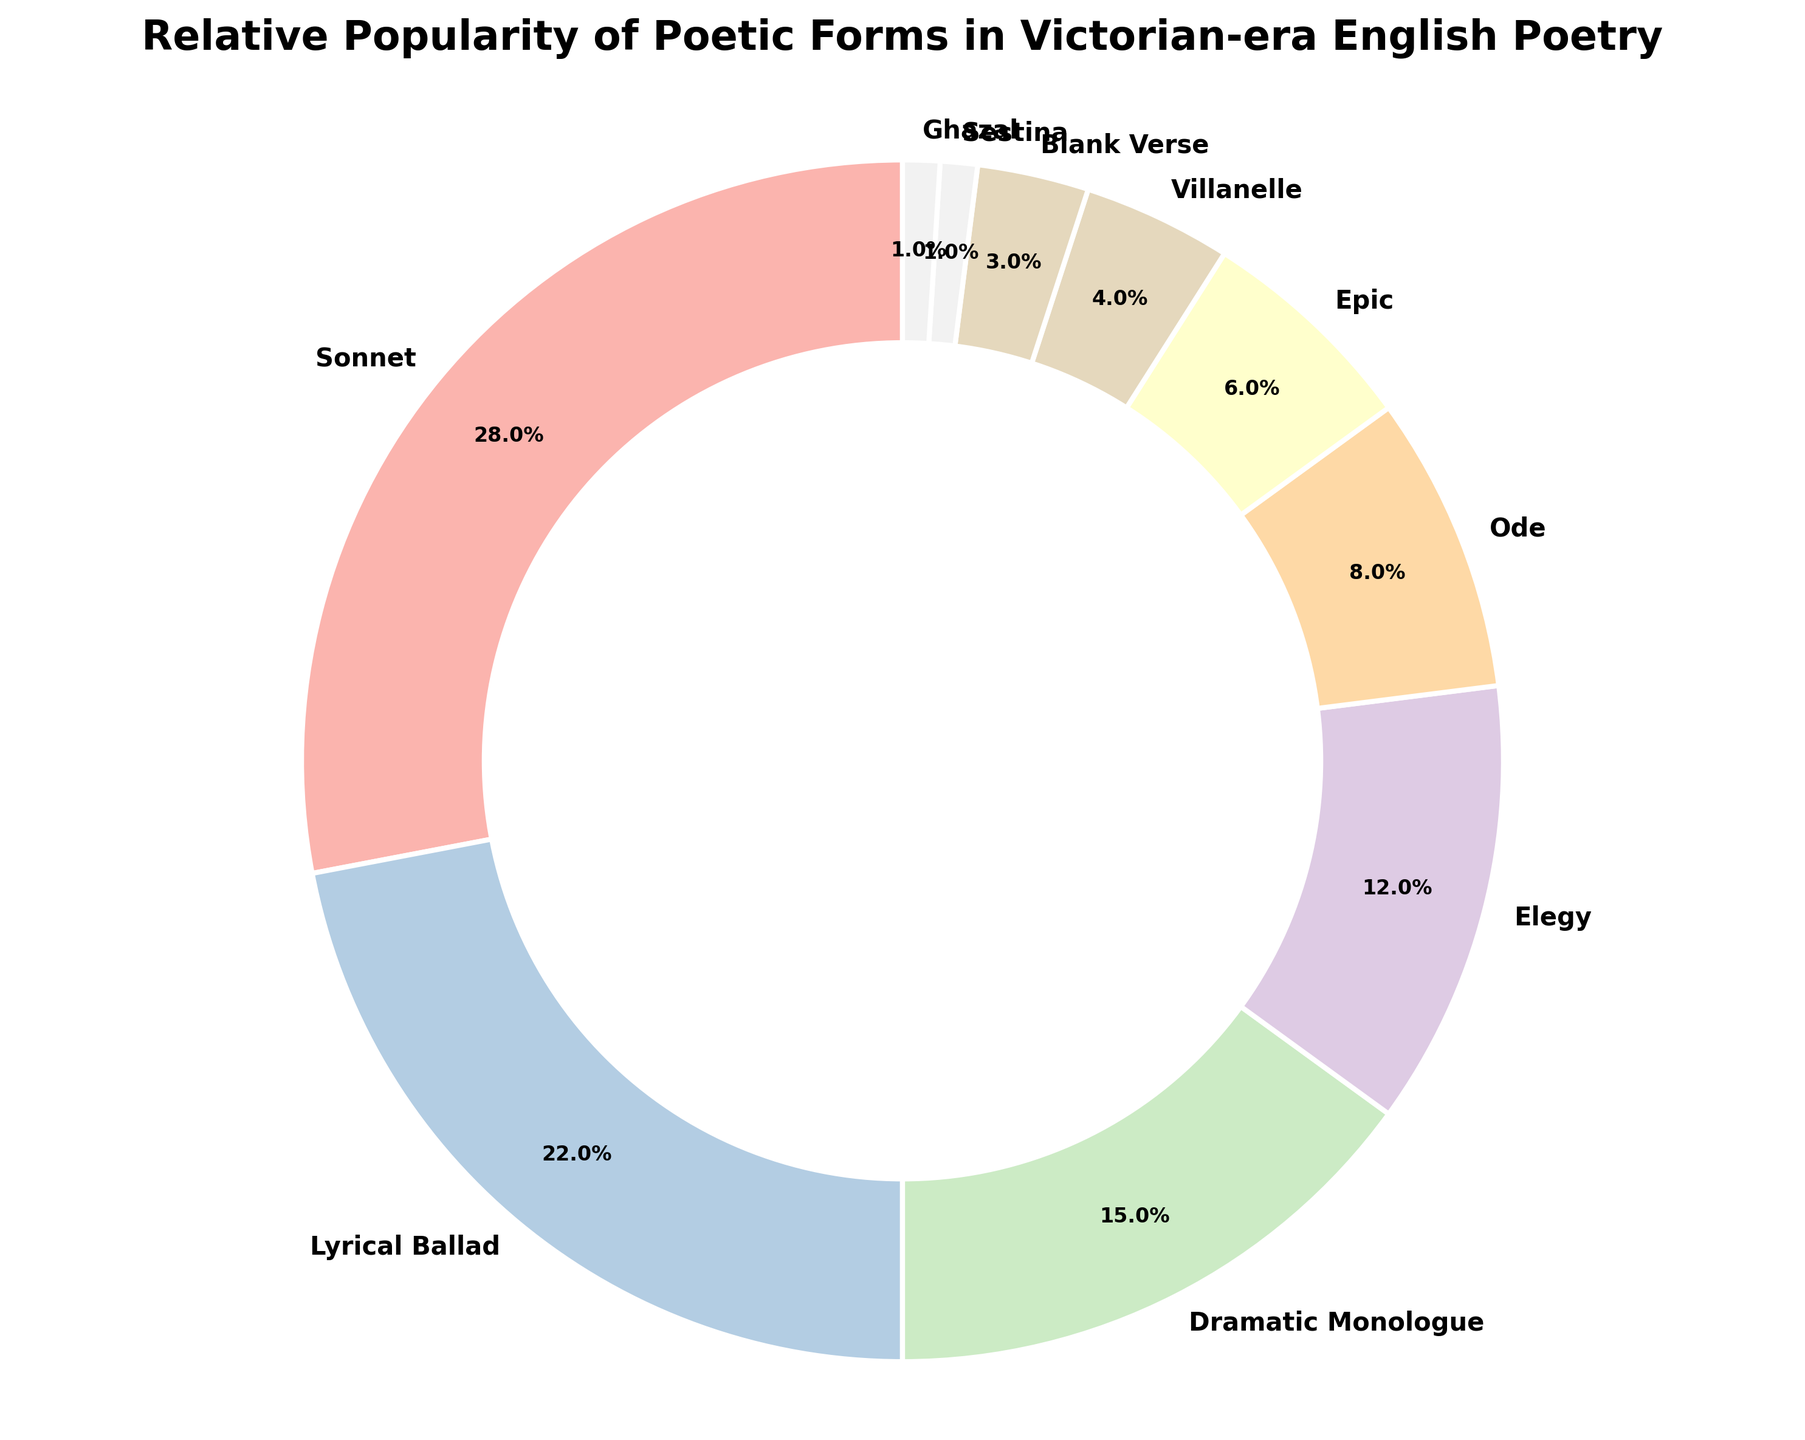Which poetic form is the most popular according to the chart? The largest portion of the pie chart represents the "Sonnet" section at 28%.
Answer: Sonnet Which poetic forms combined cover more than half of the relative popularity in the chart? The Sonnet (28%) and Lyrical Ballad (22%) combined make up 50%, which, together with the Dramatic Monologue (15%), brings the total to 65%, surpassing half of the entire chart.
Answer: Sonnet, Lyrical Ballad, Dramatic Monologue How much more popular are Sonnets compared to Villanelles? The popularity of Sonnets is 28% and for Villanelles is 4%. Subtracting the latter from the former, 28% - 4% = 24%.
Answer: 24% Which poetic form ranks just above the Ghazal in popularity? Ghazals have a 1% share, and the next least popular form is the Sestina with 1% (though it's equal) followed by Blank Verse with 3%.
Answer: Sestina What is the sum of the percentages of Epic and Ode forms? The Epic form has a 6% share and the Ode form has an 8% share. Their combined total is 6% + 8% = 14%.
Answer: 14% How do the percentages of the Elegy and the Dramatic Monologue compare? The Elegy has a 12% share, while the Dramatic Monologue has a 15% share; 15% - 12% = 3%, showing the Dramatic Monologue is 3% more popular.
Answer: Dramatic Monologue is 3% more popular What percentage of the chart is occupied by poetic forms less popular than the Ode? Forms less popular than the Ode (8%) are Epic (6%), Villanelle (4%), Blank Verse (3%), Sestina (1%), and Ghazal (1%). Their sum is 6% + 4% + 3% + 1% + 1% = 15%.
Answer: 15% How much more popular are Lyrical Ballads compared to Blank Verse and Villanelle combined? Lyrical Ballads are at 22%, while Blank Verse is at 3% and Villanelle is at 4%, summing to 7%. The difference is 22% - 7% = 15%.
Answer: 15% What fraction of the chart is occupied by Sonnets and Elegy forms combined? Sonnets have 28% and Elegy has 12%, together they make up 28% + 12% = 40%. As a fraction of the total, this is 40/100 or 2/5.
Answer: 2/5 